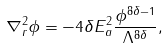<formula> <loc_0><loc_0><loc_500><loc_500>\nabla ^ { 2 } _ { r } \phi = - 4 \delta E _ { a } ^ { 2 } \frac { \phi ^ { 8 \delta - 1 } } { \Lambda ^ { 8 \delta } } ,</formula> 